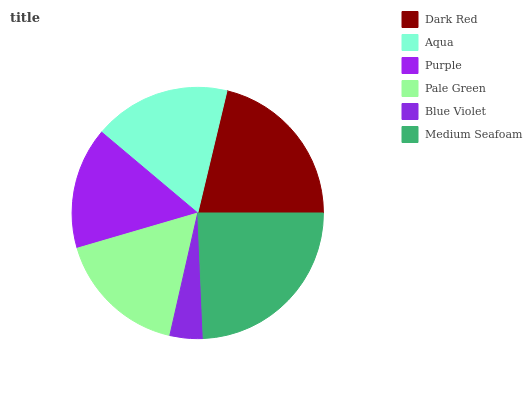Is Blue Violet the minimum?
Answer yes or no. Yes. Is Medium Seafoam the maximum?
Answer yes or no. Yes. Is Aqua the minimum?
Answer yes or no. No. Is Aqua the maximum?
Answer yes or no. No. Is Dark Red greater than Aqua?
Answer yes or no. Yes. Is Aqua less than Dark Red?
Answer yes or no. Yes. Is Aqua greater than Dark Red?
Answer yes or no. No. Is Dark Red less than Aqua?
Answer yes or no. No. Is Aqua the high median?
Answer yes or no. Yes. Is Pale Green the low median?
Answer yes or no. Yes. Is Purple the high median?
Answer yes or no. No. Is Blue Violet the low median?
Answer yes or no. No. 